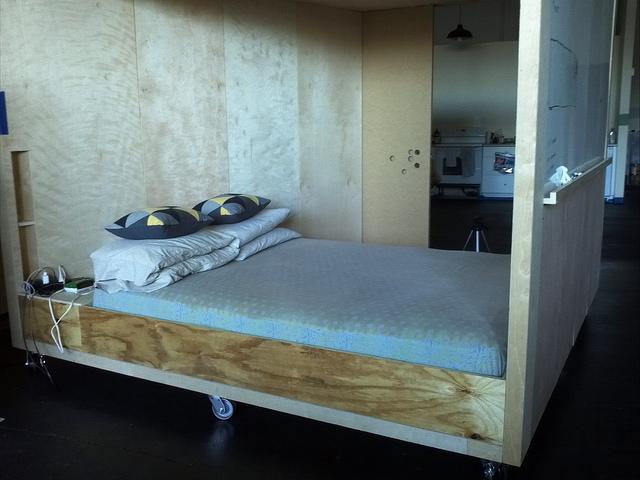Does the bed touch the ground?
Be succinct. No. Does this bed look expensive?
Short answer required. No. How many pillows?
Concise answer only. 6. 